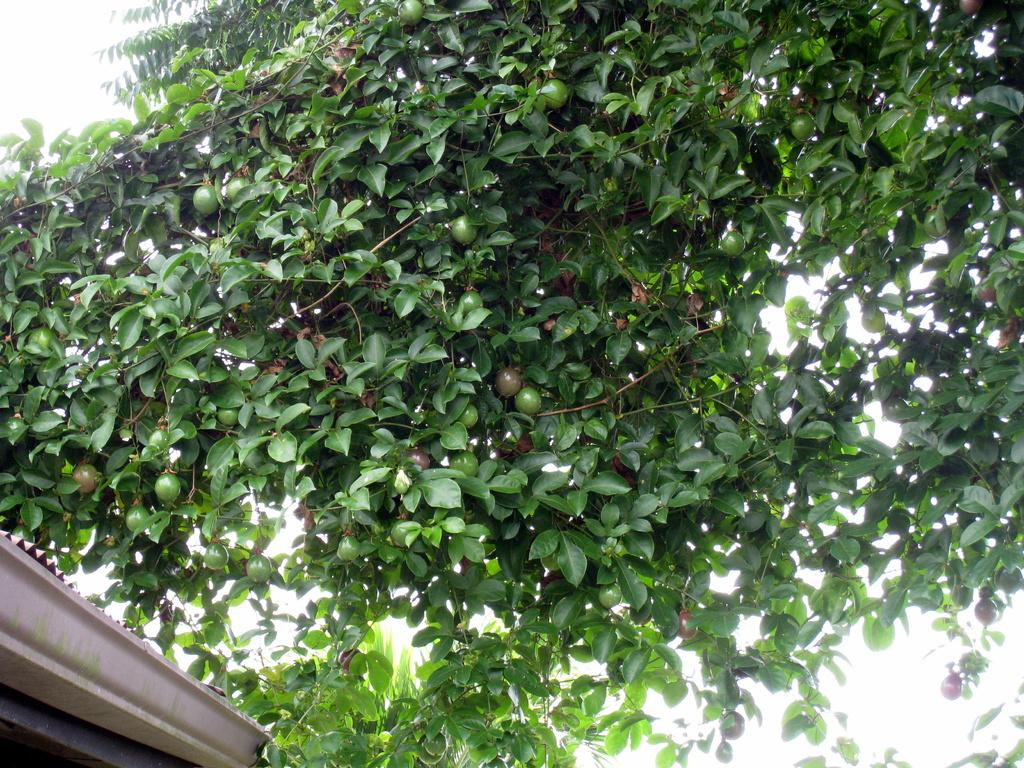What is present in the image? There is a tree in the image. What can be observed about the tree's fruits? The tree has green fruits. What else is present on the tree besides the fruits? The tree has leaves. How does the turkey run around the tree in the image? There is no turkey present in the image, so it cannot run around the tree. 